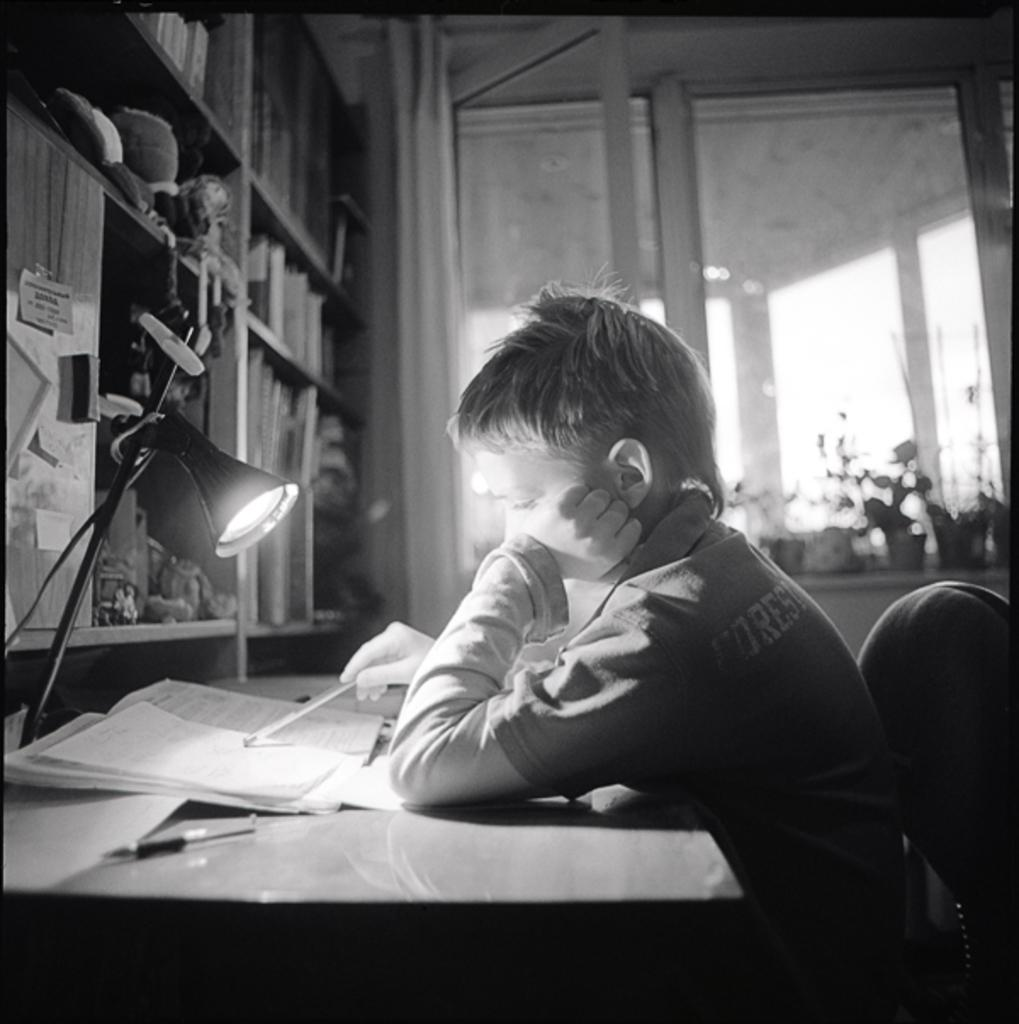What is the main subject of the image? The main subject of the image is a boy. What is the boy doing in the image? The boy is seated on a chair and reading a book. Where is the book located in the image? The book is on a table. What object in the image might provide light for the boy to read? There is a lamp in the image. What type of ship can be seen sailing in the background of the image? There is no ship present in the image; it features a boy reading a book. How many arms does the boy have in the image? The boy has two arms in the image, as is typical for humans. 